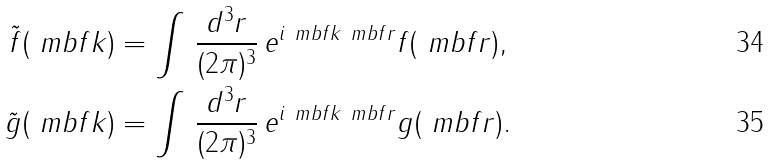<formula> <loc_0><loc_0><loc_500><loc_500>\tilde { f } ( \ m b f { k } ) & = \int \, \frac { d ^ { 3 } r } { ( 2 \pi ) ^ { 3 } } \, e ^ { i \ m b f { k } \ m b f { r } } f ( \ m b f { r } ) , \\ \tilde { g } ( \ m b f { k } ) & = \int \, \frac { d ^ { 3 } r } { ( 2 \pi ) ^ { 3 } } \, e ^ { i \ m b f { k } \ m b f { r } } g ( \ m b f { r } ) .</formula> 